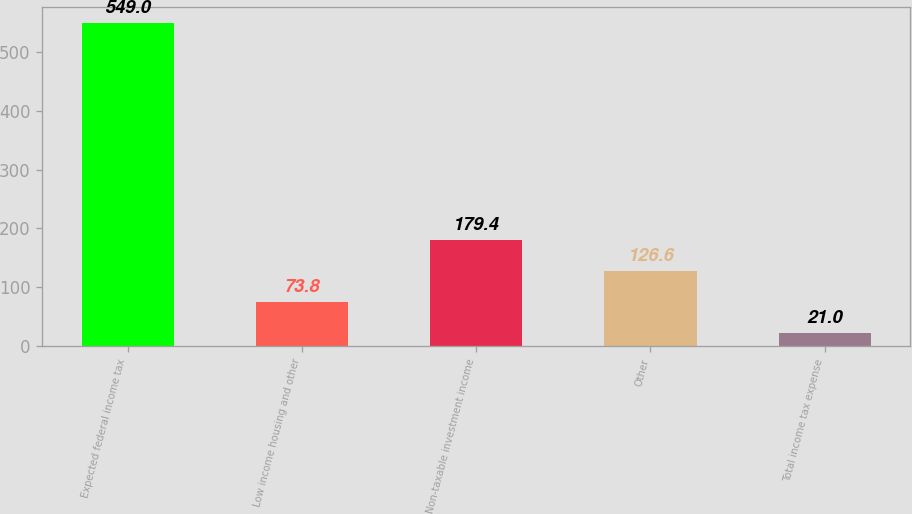Convert chart to OTSL. <chart><loc_0><loc_0><loc_500><loc_500><bar_chart><fcel>Expected federal income tax<fcel>Low income housing and other<fcel>Non-taxable investment income<fcel>Other<fcel>Total income tax expense<nl><fcel>549<fcel>73.8<fcel>179.4<fcel>126.6<fcel>21<nl></chart> 